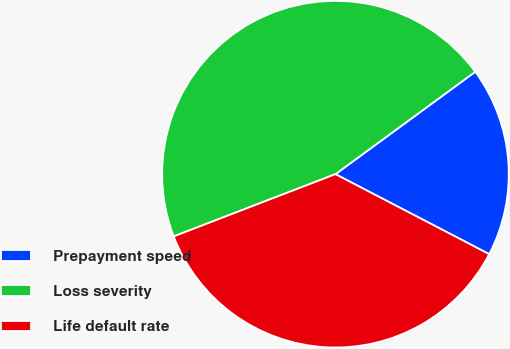Convert chart to OTSL. <chart><loc_0><loc_0><loc_500><loc_500><pie_chart><fcel>Prepayment speed<fcel>Loss severity<fcel>Life default rate<nl><fcel>17.7%<fcel>45.79%<fcel>36.52%<nl></chart> 